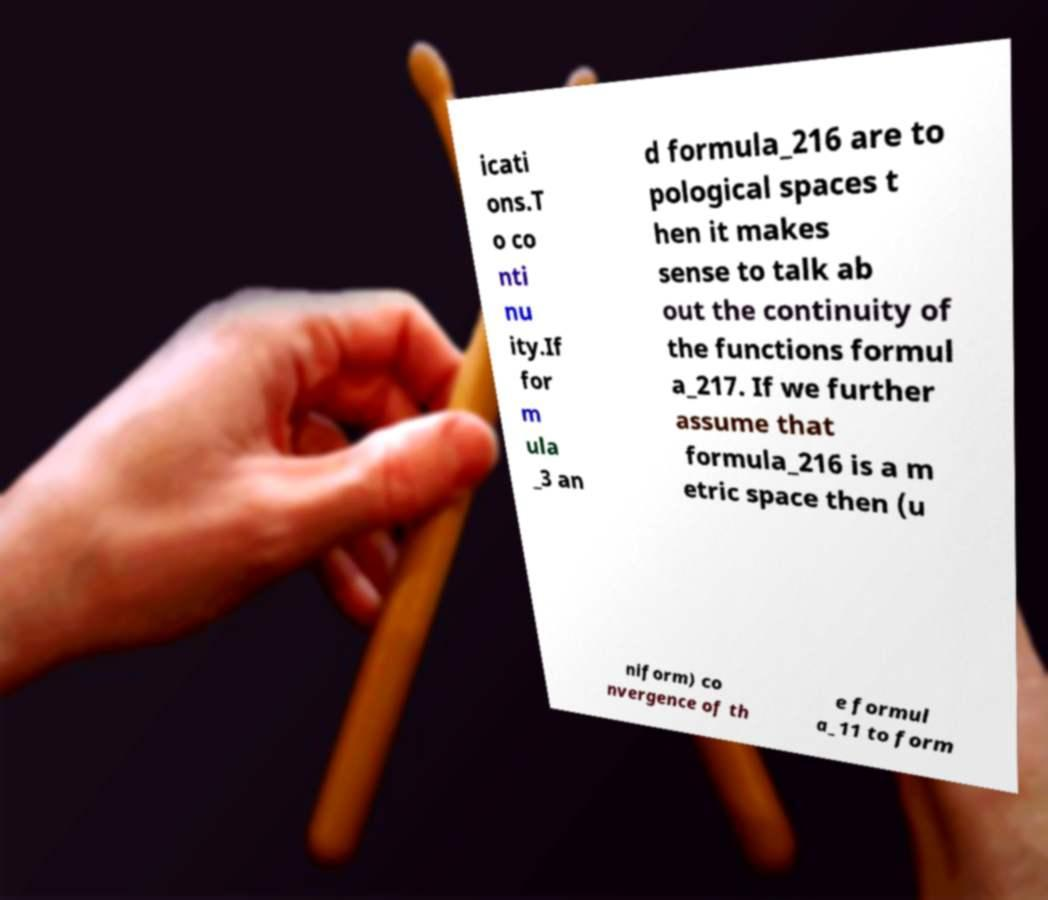For documentation purposes, I need the text within this image transcribed. Could you provide that? icati ons.T o co nti nu ity.If for m ula _3 an d formula_216 are to pological spaces t hen it makes sense to talk ab out the continuity of the functions formul a_217. If we further assume that formula_216 is a m etric space then (u niform) co nvergence of th e formul a_11 to form 